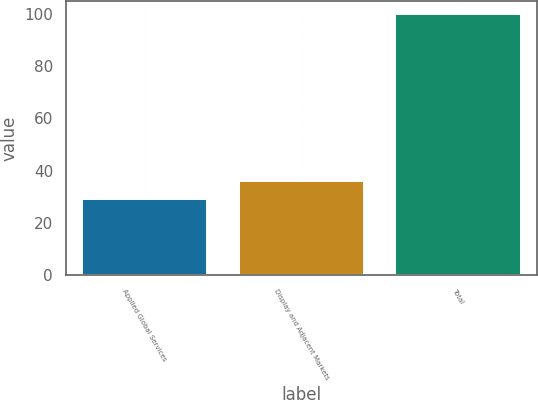<chart> <loc_0><loc_0><loc_500><loc_500><bar_chart><fcel>Applied Global Services<fcel>Display and Adjacent Markets<fcel>Total<nl><fcel>29<fcel>36.1<fcel>100<nl></chart> 